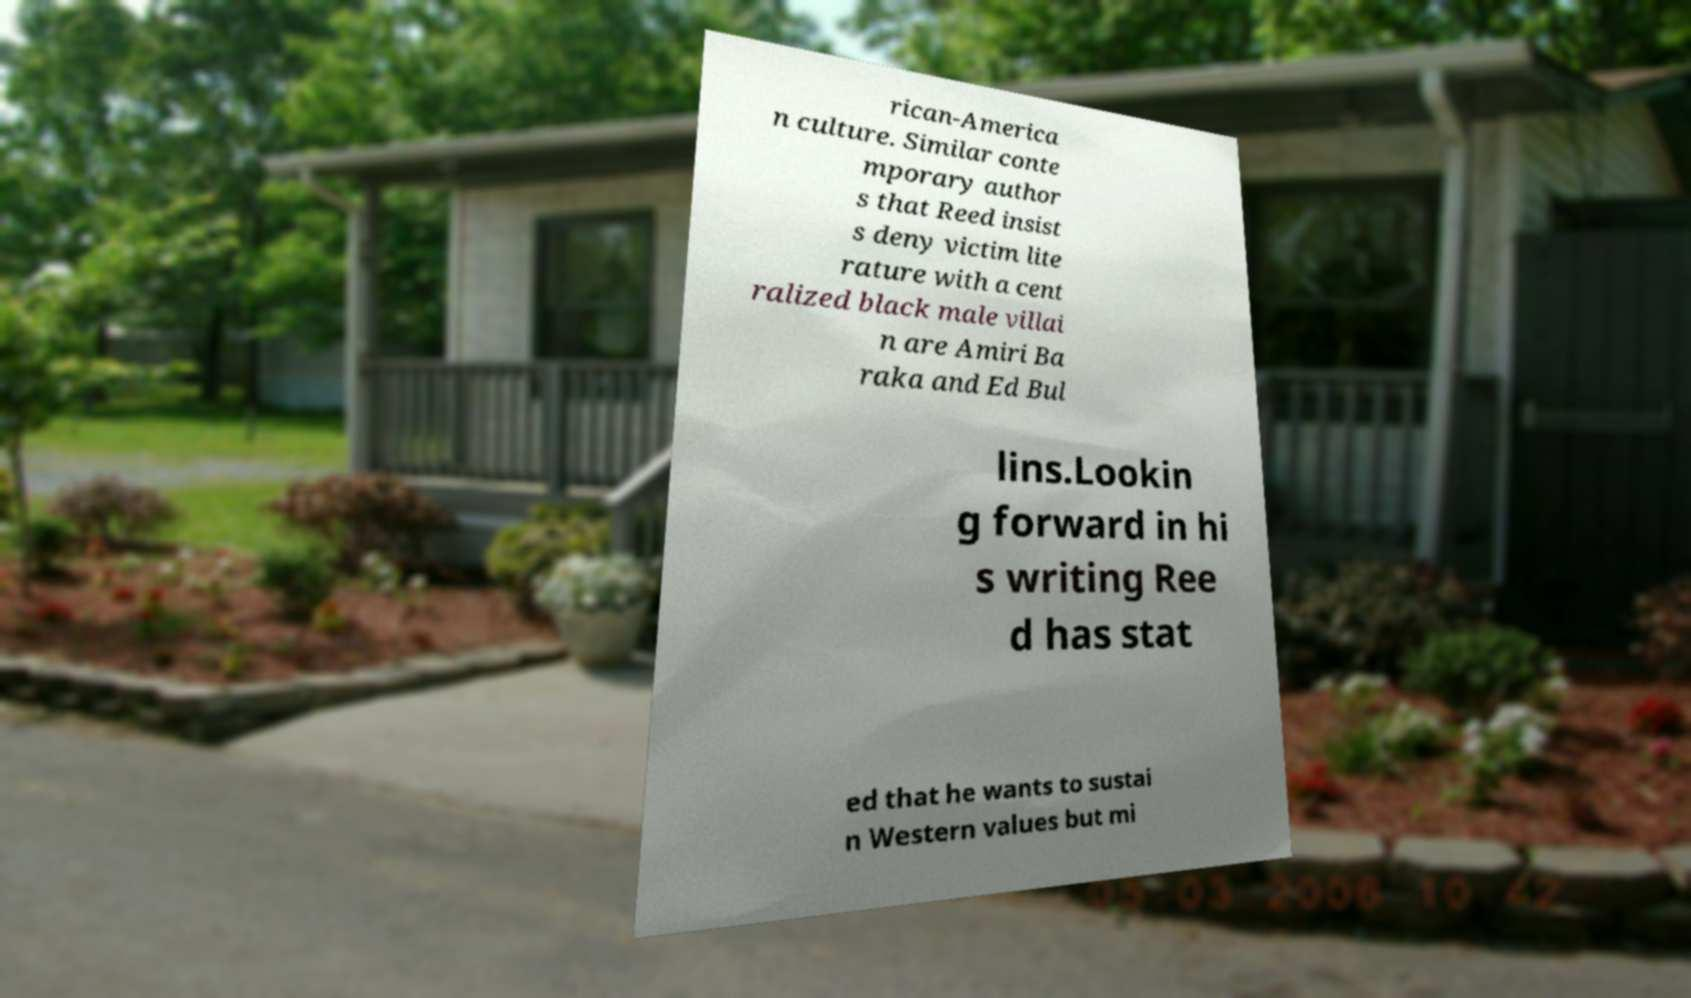Please identify and transcribe the text found in this image. rican-America n culture. Similar conte mporary author s that Reed insist s deny victim lite rature with a cent ralized black male villai n are Amiri Ba raka and Ed Bul lins.Lookin g forward in hi s writing Ree d has stat ed that he wants to sustai n Western values but mi 